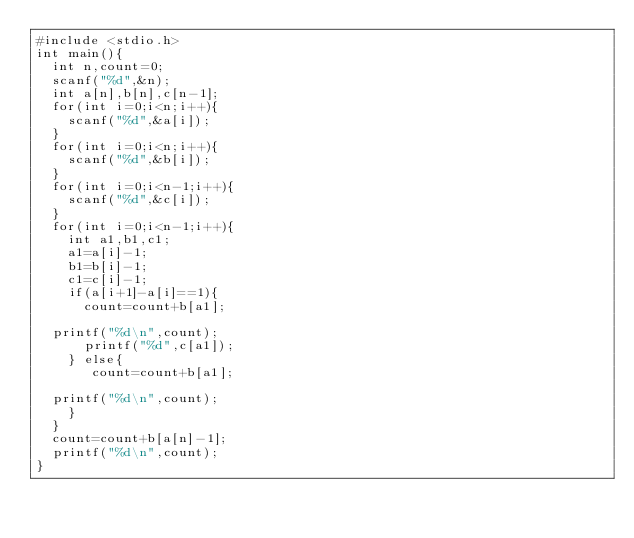Convert code to text. <code><loc_0><loc_0><loc_500><loc_500><_C_>#include <stdio.h>
int main(){
  int n,count=0;
  scanf("%d",&n);
  int a[n],b[n],c[n-1];
  for(int i=0;i<n;i++){
    scanf("%d",&a[i]);
  }
  for(int i=0;i<n;i++){
    scanf("%d",&b[i]);
  }
  for(int i=0;i<n-1;i++){
    scanf("%d",&c[i]);
  }
  for(int i=0;i<n-1;i++){
    int a1,b1,c1;
    a1=a[i]-1;
    b1=b[i]-1;
    c1=c[i]-1;
    if(a[i+1]-a[i]==1){
      count=count+b[a1];
      
  printf("%d\n",count); 
      printf("%d",c[a1]);
    } else{
       count=count+b[a1];
      
  printf("%d\n",count); 
    }
  }
  count=count+b[a[n]-1];
  printf("%d\n",count); 
}
    </code> 